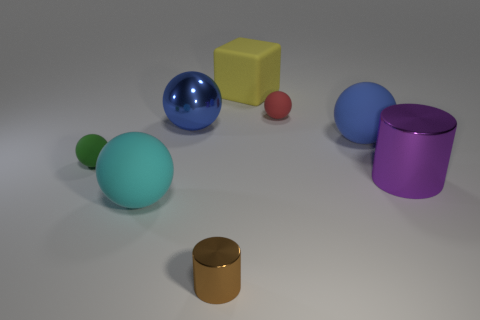Subtract all tiny green spheres. How many spheres are left? 4 Subtract all red spheres. How many spheres are left? 4 Subtract all blocks. How many objects are left? 7 Subtract all blue cubes. How many blue balls are left? 2 Add 1 big cyan spheres. How many objects exist? 9 Add 6 brown things. How many brown things are left? 7 Add 2 blue metal objects. How many blue metal objects exist? 3 Subtract 0 yellow spheres. How many objects are left? 8 Subtract all cyan blocks. Subtract all red cylinders. How many blocks are left? 1 Subtract all small green spheres. Subtract all big blue spheres. How many objects are left? 5 